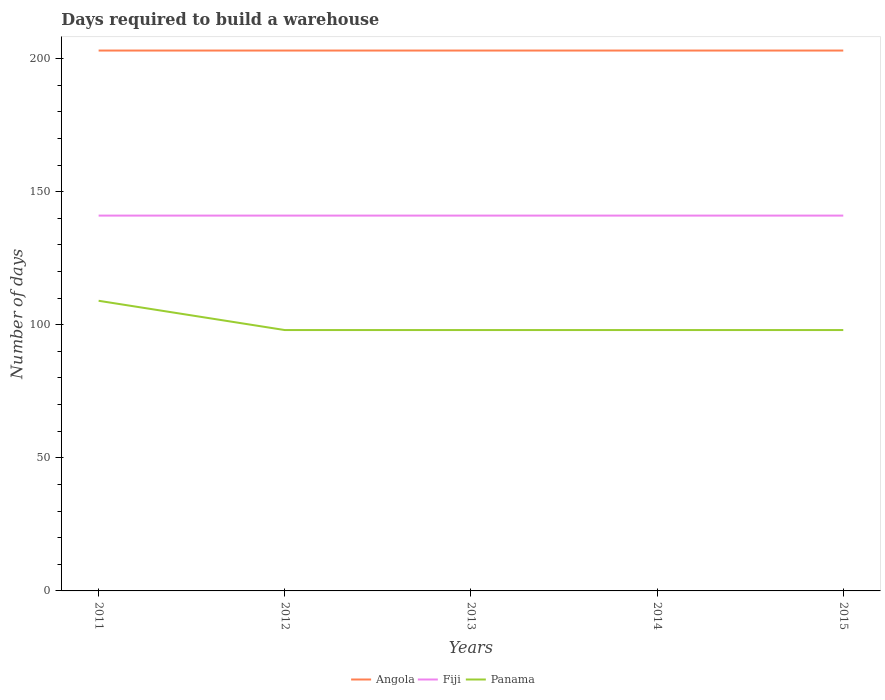How many different coloured lines are there?
Your response must be concise. 3. Is the number of lines equal to the number of legend labels?
Keep it short and to the point. Yes. Across all years, what is the maximum days required to build a warehouse in in Fiji?
Keep it short and to the point. 141. What is the total days required to build a warehouse in in Fiji in the graph?
Offer a terse response. 0. How many lines are there?
Offer a very short reply. 3. What is the difference between two consecutive major ticks on the Y-axis?
Your answer should be compact. 50. Does the graph contain any zero values?
Offer a terse response. No. What is the title of the graph?
Provide a succinct answer. Days required to build a warehouse. What is the label or title of the X-axis?
Provide a succinct answer. Years. What is the label or title of the Y-axis?
Ensure brevity in your answer.  Number of days. What is the Number of days in Angola in 2011?
Provide a succinct answer. 203. What is the Number of days of Fiji in 2011?
Give a very brief answer. 141. What is the Number of days in Panama in 2011?
Your answer should be very brief. 109. What is the Number of days in Angola in 2012?
Make the answer very short. 203. What is the Number of days of Fiji in 2012?
Offer a very short reply. 141. What is the Number of days of Angola in 2013?
Your response must be concise. 203. What is the Number of days of Fiji in 2013?
Offer a terse response. 141. What is the Number of days of Angola in 2014?
Your answer should be compact. 203. What is the Number of days of Fiji in 2014?
Your response must be concise. 141. What is the Number of days of Panama in 2014?
Provide a succinct answer. 98. What is the Number of days of Angola in 2015?
Ensure brevity in your answer.  203. What is the Number of days in Fiji in 2015?
Offer a terse response. 141. Across all years, what is the maximum Number of days of Angola?
Provide a succinct answer. 203. Across all years, what is the maximum Number of days of Fiji?
Keep it short and to the point. 141. Across all years, what is the maximum Number of days in Panama?
Offer a terse response. 109. Across all years, what is the minimum Number of days of Angola?
Offer a very short reply. 203. Across all years, what is the minimum Number of days of Fiji?
Give a very brief answer. 141. Across all years, what is the minimum Number of days of Panama?
Ensure brevity in your answer.  98. What is the total Number of days in Angola in the graph?
Provide a succinct answer. 1015. What is the total Number of days in Fiji in the graph?
Your response must be concise. 705. What is the total Number of days in Panama in the graph?
Provide a short and direct response. 501. What is the difference between the Number of days in Angola in 2011 and that in 2012?
Keep it short and to the point. 0. What is the difference between the Number of days of Fiji in 2011 and that in 2012?
Your answer should be compact. 0. What is the difference between the Number of days in Panama in 2011 and that in 2012?
Offer a very short reply. 11. What is the difference between the Number of days of Angola in 2011 and that in 2013?
Your answer should be very brief. 0. What is the difference between the Number of days of Fiji in 2011 and that in 2013?
Offer a terse response. 0. What is the difference between the Number of days of Panama in 2011 and that in 2013?
Provide a short and direct response. 11. What is the difference between the Number of days in Angola in 2011 and that in 2014?
Ensure brevity in your answer.  0. What is the difference between the Number of days of Fiji in 2011 and that in 2014?
Offer a very short reply. 0. What is the difference between the Number of days of Fiji in 2011 and that in 2015?
Give a very brief answer. 0. What is the difference between the Number of days in Angola in 2012 and that in 2013?
Your response must be concise. 0. What is the difference between the Number of days in Panama in 2012 and that in 2013?
Keep it short and to the point. 0. What is the difference between the Number of days of Angola in 2012 and that in 2015?
Make the answer very short. 0. What is the difference between the Number of days of Panama in 2012 and that in 2015?
Make the answer very short. 0. What is the difference between the Number of days of Panama in 2013 and that in 2014?
Provide a succinct answer. 0. What is the difference between the Number of days in Angola in 2013 and that in 2015?
Your answer should be compact. 0. What is the difference between the Number of days of Angola in 2014 and that in 2015?
Your answer should be very brief. 0. What is the difference between the Number of days of Fiji in 2014 and that in 2015?
Your answer should be compact. 0. What is the difference between the Number of days in Panama in 2014 and that in 2015?
Your response must be concise. 0. What is the difference between the Number of days of Angola in 2011 and the Number of days of Fiji in 2012?
Keep it short and to the point. 62. What is the difference between the Number of days in Angola in 2011 and the Number of days in Panama in 2012?
Provide a short and direct response. 105. What is the difference between the Number of days of Fiji in 2011 and the Number of days of Panama in 2012?
Give a very brief answer. 43. What is the difference between the Number of days of Angola in 2011 and the Number of days of Fiji in 2013?
Offer a terse response. 62. What is the difference between the Number of days in Angola in 2011 and the Number of days in Panama in 2013?
Ensure brevity in your answer.  105. What is the difference between the Number of days in Angola in 2011 and the Number of days in Panama in 2014?
Your answer should be very brief. 105. What is the difference between the Number of days in Angola in 2011 and the Number of days in Panama in 2015?
Provide a short and direct response. 105. What is the difference between the Number of days of Fiji in 2011 and the Number of days of Panama in 2015?
Your answer should be very brief. 43. What is the difference between the Number of days of Angola in 2012 and the Number of days of Fiji in 2013?
Provide a short and direct response. 62. What is the difference between the Number of days in Angola in 2012 and the Number of days in Panama in 2013?
Offer a terse response. 105. What is the difference between the Number of days in Angola in 2012 and the Number of days in Fiji in 2014?
Ensure brevity in your answer.  62. What is the difference between the Number of days of Angola in 2012 and the Number of days of Panama in 2014?
Keep it short and to the point. 105. What is the difference between the Number of days of Fiji in 2012 and the Number of days of Panama in 2014?
Provide a succinct answer. 43. What is the difference between the Number of days of Angola in 2012 and the Number of days of Panama in 2015?
Make the answer very short. 105. What is the difference between the Number of days of Angola in 2013 and the Number of days of Fiji in 2014?
Offer a terse response. 62. What is the difference between the Number of days in Angola in 2013 and the Number of days in Panama in 2014?
Make the answer very short. 105. What is the difference between the Number of days of Angola in 2013 and the Number of days of Panama in 2015?
Give a very brief answer. 105. What is the difference between the Number of days of Angola in 2014 and the Number of days of Panama in 2015?
Make the answer very short. 105. What is the average Number of days in Angola per year?
Provide a succinct answer. 203. What is the average Number of days of Fiji per year?
Your answer should be compact. 141. What is the average Number of days of Panama per year?
Offer a very short reply. 100.2. In the year 2011, what is the difference between the Number of days of Angola and Number of days of Fiji?
Your response must be concise. 62. In the year 2011, what is the difference between the Number of days of Angola and Number of days of Panama?
Give a very brief answer. 94. In the year 2011, what is the difference between the Number of days of Fiji and Number of days of Panama?
Your response must be concise. 32. In the year 2012, what is the difference between the Number of days in Angola and Number of days in Panama?
Your response must be concise. 105. In the year 2012, what is the difference between the Number of days of Fiji and Number of days of Panama?
Give a very brief answer. 43. In the year 2013, what is the difference between the Number of days of Angola and Number of days of Panama?
Offer a very short reply. 105. In the year 2013, what is the difference between the Number of days in Fiji and Number of days in Panama?
Provide a short and direct response. 43. In the year 2014, what is the difference between the Number of days of Angola and Number of days of Fiji?
Ensure brevity in your answer.  62. In the year 2014, what is the difference between the Number of days of Angola and Number of days of Panama?
Offer a very short reply. 105. In the year 2014, what is the difference between the Number of days in Fiji and Number of days in Panama?
Offer a terse response. 43. In the year 2015, what is the difference between the Number of days of Angola and Number of days of Fiji?
Provide a short and direct response. 62. In the year 2015, what is the difference between the Number of days of Angola and Number of days of Panama?
Give a very brief answer. 105. In the year 2015, what is the difference between the Number of days of Fiji and Number of days of Panama?
Make the answer very short. 43. What is the ratio of the Number of days in Angola in 2011 to that in 2012?
Your answer should be very brief. 1. What is the ratio of the Number of days in Fiji in 2011 to that in 2012?
Offer a very short reply. 1. What is the ratio of the Number of days in Panama in 2011 to that in 2012?
Your answer should be compact. 1.11. What is the ratio of the Number of days in Fiji in 2011 to that in 2013?
Your answer should be very brief. 1. What is the ratio of the Number of days of Panama in 2011 to that in 2013?
Give a very brief answer. 1.11. What is the ratio of the Number of days of Angola in 2011 to that in 2014?
Offer a very short reply. 1. What is the ratio of the Number of days in Panama in 2011 to that in 2014?
Provide a short and direct response. 1.11. What is the ratio of the Number of days in Panama in 2011 to that in 2015?
Ensure brevity in your answer.  1.11. What is the ratio of the Number of days of Fiji in 2012 to that in 2013?
Offer a terse response. 1. What is the ratio of the Number of days in Panama in 2012 to that in 2013?
Your answer should be very brief. 1. What is the ratio of the Number of days in Panama in 2012 to that in 2014?
Make the answer very short. 1. What is the ratio of the Number of days of Fiji in 2012 to that in 2015?
Your answer should be compact. 1. What is the ratio of the Number of days in Angola in 2013 to that in 2014?
Offer a terse response. 1. What is the ratio of the Number of days of Fiji in 2013 to that in 2014?
Provide a short and direct response. 1. What is the ratio of the Number of days in Angola in 2013 to that in 2015?
Give a very brief answer. 1. What is the ratio of the Number of days in Fiji in 2013 to that in 2015?
Provide a short and direct response. 1. What is the ratio of the Number of days in Panama in 2013 to that in 2015?
Offer a terse response. 1. What is the ratio of the Number of days in Angola in 2014 to that in 2015?
Offer a very short reply. 1. What is the ratio of the Number of days in Fiji in 2014 to that in 2015?
Your answer should be compact. 1. What is the ratio of the Number of days in Panama in 2014 to that in 2015?
Your answer should be very brief. 1. What is the difference between the highest and the second highest Number of days in Angola?
Your response must be concise. 0. What is the difference between the highest and the second highest Number of days of Panama?
Ensure brevity in your answer.  11. What is the difference between the highest and the lowest Number of days in Fiji?
Provide a short and direct response. 0. 